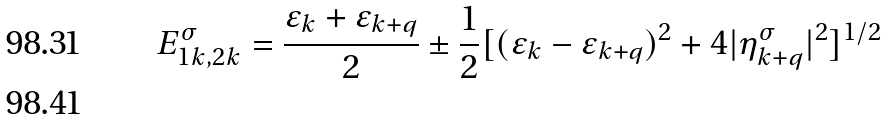<formula> <loc_0><loc_0><loc_500><loc_500>E _ { 1 k , 2 k } ^ { \sigma } = \frac { \varepsilon _ { k } + \varepsilon _ { k + q } } 2 \pm \frac { 1 } { 2 } [ ( \varepsilon _ { k } - \varepsilon _ { k + q } ) ^ { 2 } + 4 | \eta _ { k + q } ^ { \sigma } | ^ { 2 } ] ^ { 1 / 2 } \\</formula> 